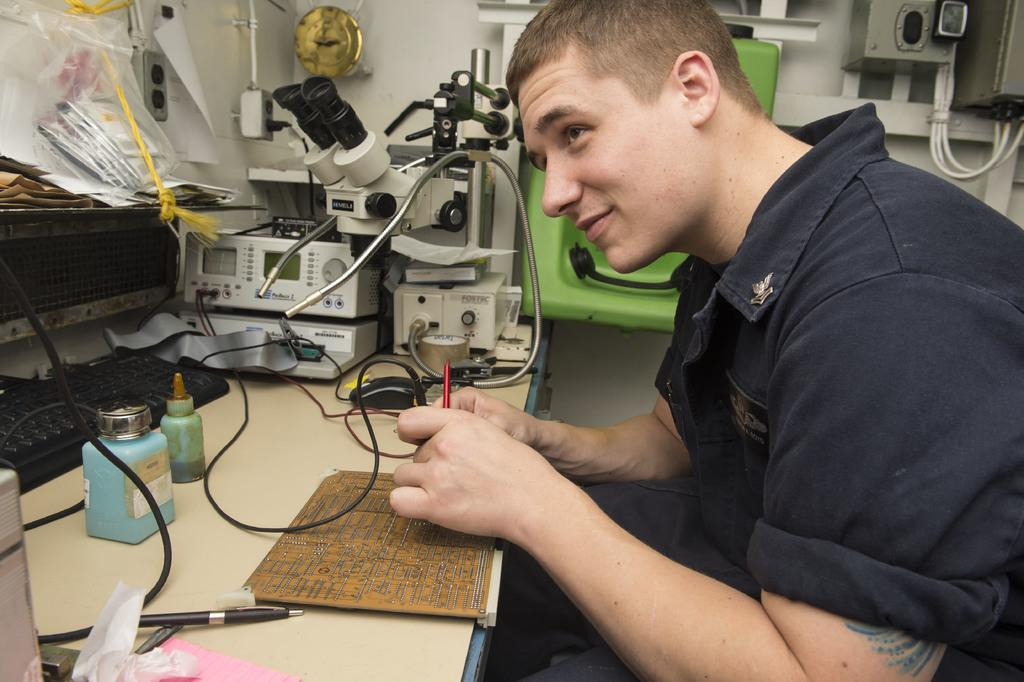Who or what is present in the image? There is a person in the image. What is the person interacting with in the image? There is a table in the image, and the person is likely interacting with the devices and objects on the table. What type of devices can be seen on the table? There are devices on the table, including a keyboard. What other objects are on the table? There are objects on the table, but their specific nature is not mentioned in the facts. What is the person holding in the image? The person is holding an object, but its specific nature is not mentioned in the facts. What writing instrument is present in the image? There is a pen in the image. What beverage container is present in the image? There is a bottle in the image. What type of soil is the person digging with a spade in the image? There is no spade or soil present in the image; it features a person interacting with a table and its contents. 